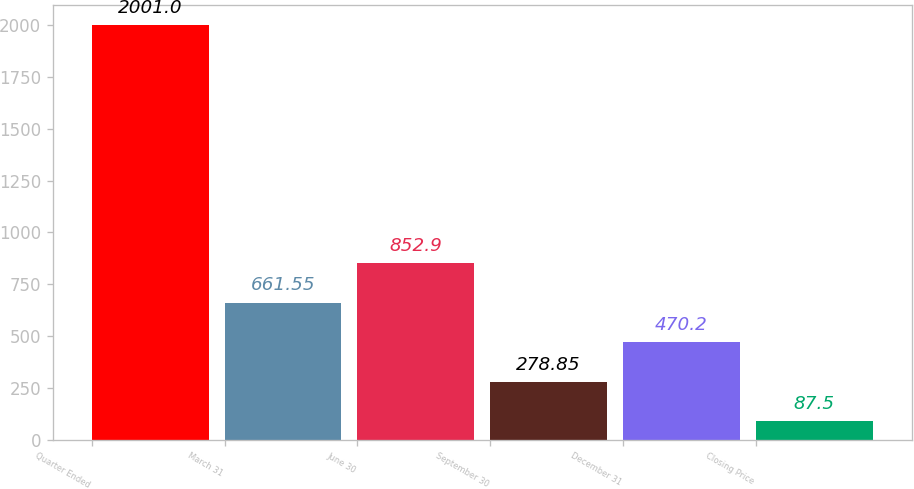<chart> <loc_0><loc_0><loc_500><loc_500><bar_chart><fcel>Quarter Ended<fcel>March 31<fcel>June 30<fcel>September 30<fcel>December 31<fcel>Closing Price<nl><fcel>2001<fcel>661.55<fcel>852.9<fcel>278.85<fcel>470.2<fcel>87.5<nl></chart> 